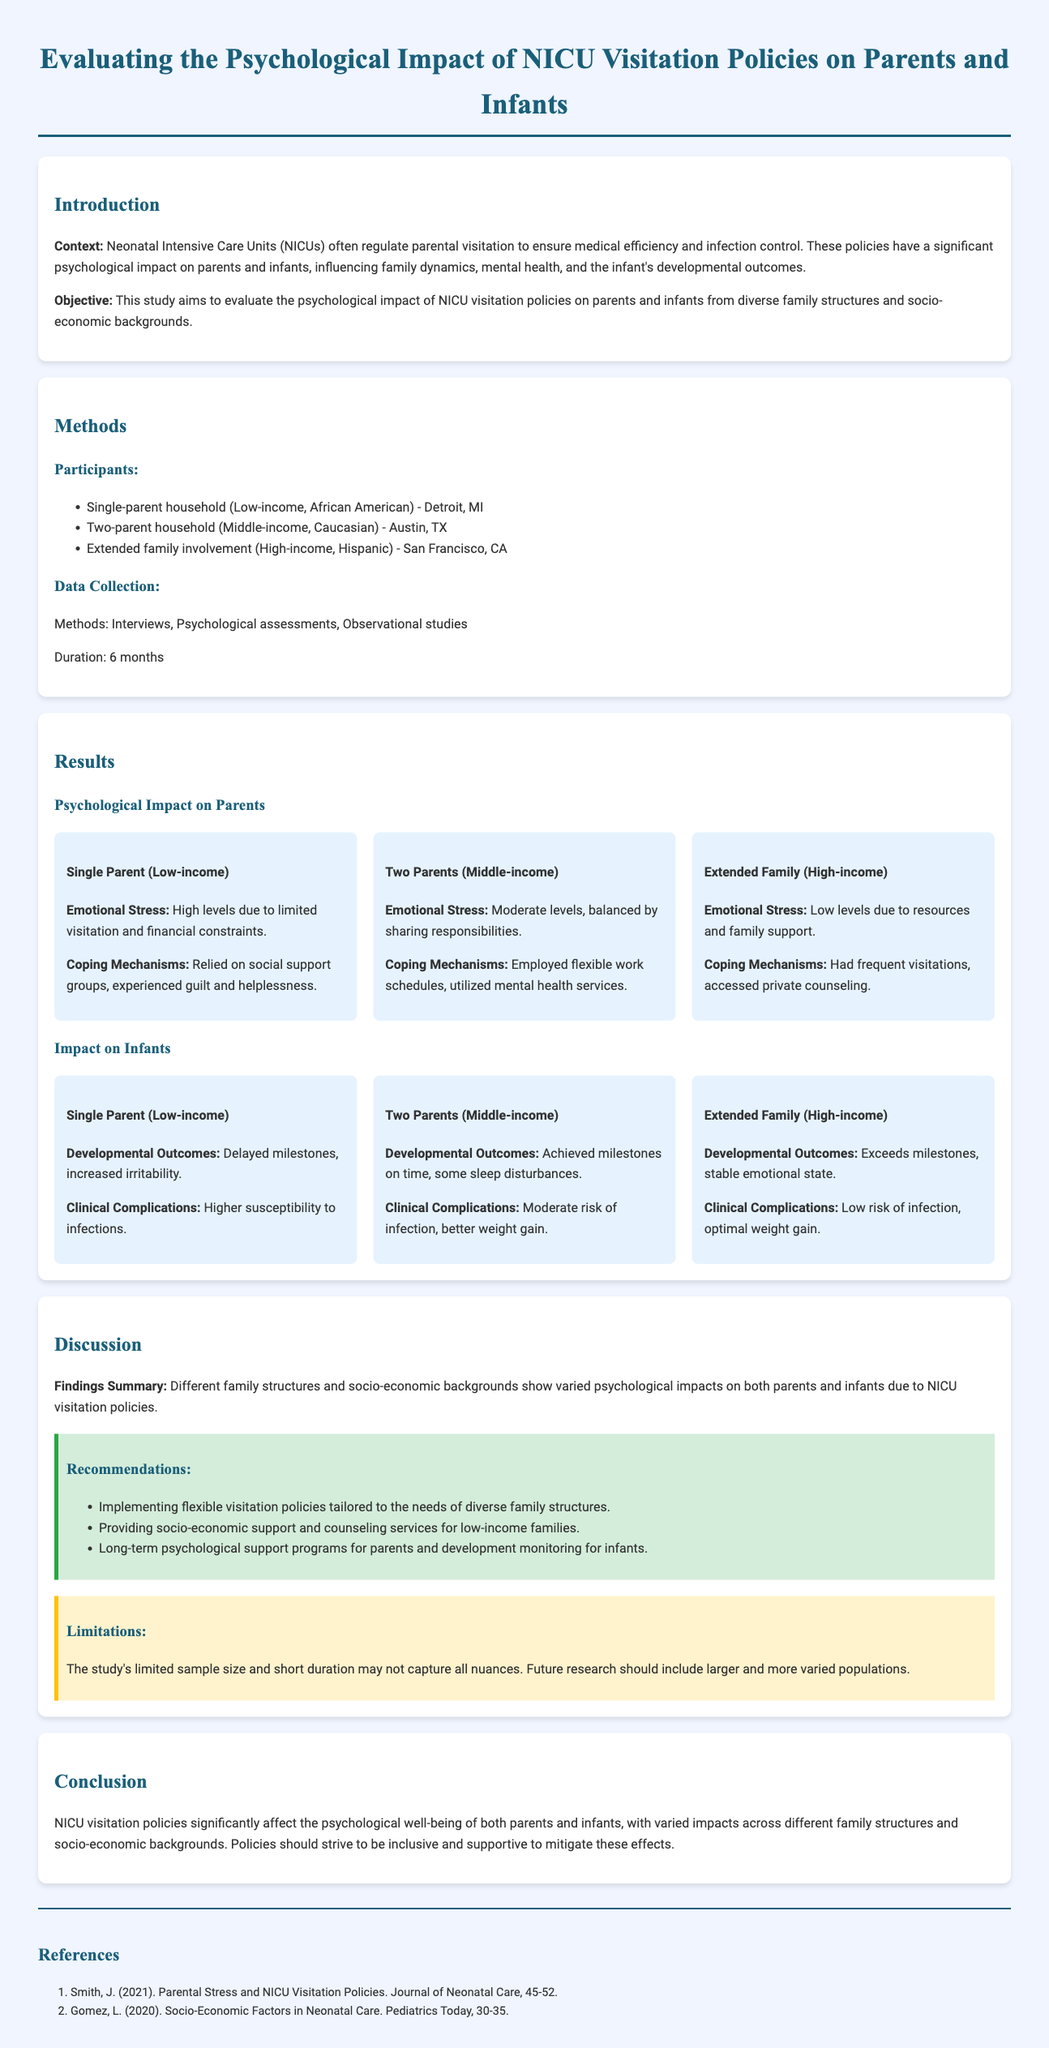what is the main objective of the study? The objective of the study is to evaluate the psychological impact of NICU visitation policies on parents and infants from diverse family structures and socio-economic backgrounds.
Answer: to evaluate the psychological impact of NICU visitation policies on parents and infants from diverse family structures and socio-economic backgrounds how long was the data collection period? The data collection period lasted for 6 months as mentioned in the methods section.
Answer: 6 months what was the emotional stress level for the single parent (low-income)? The emotional stress level for the single parent (low-income) was described as high due to limited visitation and financial constraints.
Answer: High levels what coping mechanism was employed by the two-parent household (middle-income)? The two-parent household (middle-income) employed flexible work schedules as a coping mechanism.
Answer: Flexible work schedules which family structure had the lowest emotional stress? The extended family involvement (high-income) had the lowest emotional stress according to the results section.
Answer: Extended family involvement what claims are made about the developmental outcomes for infants in low-income single-parent households? The document claims that infants in low-income single-parent households had delayed milestones and increased irritability.
Answer: Delayed milestones, increased irritability which recommendation suggests support for low-income families? The recommendation to provide socio-economic support and counseling services specifically mentions aiding low-income families.
Answer: Providing socio-economic support and counseling services what is one limitation of the study? One limitation mentioned is the study's limited sample size and short duration, which may not capture all nuances.
Answer: Limited sample size and short duration 